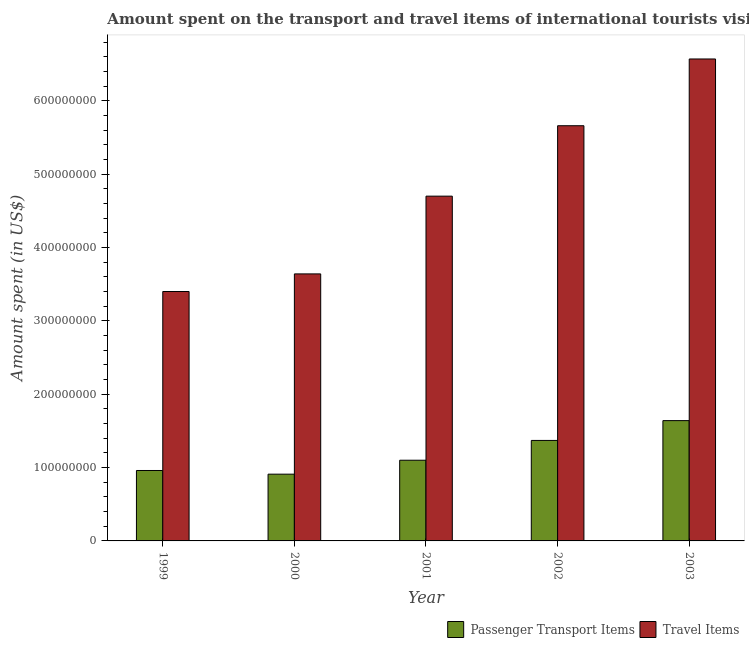How many different coloured bars are there?
Give a very brief answer. 2. What is the label of the 3rd group of bars from the left?
Provide a succinct answer. 2001. In how many cases, is the number of bars for a given year not equal to the number of legend labels?
Offer a terse response. 0. What is the amount spent on passenger transport items in 2001?
Offer a very short reply. 1.10e+08. Across all years, what is the maximum amount spent on passenger transport items?
Your response must be concise. 1.64e+08. Across all years, what is the minimum amount spent on passenger transport items?
Provide a succinct answer. 9.10e+07. In which year was the amount spent on passenger transport items maximum?
Provide a short and direct response. 2003. In which year was the amount spent in travel items minimum?
Offer a very short reply. 1999. What is the total amount spent in travel items in the graph?
Offer a terse response. 2.40e+09. What is the difference between the amount spent on passenger transport items in 2000 and that in 2002?
Offer a very short reply. -4.60e+07. What is the difference between the amount spent in travel items in 1999 and the amount spent on passenger transport items in 2002?
Provide a succinct answer. -2.26e+08. What is the average amount spent on passenger transport items per year?
Offer a very short reply. 1.20e+08. What is the ratio of the amount spent on passenger transport items in 2000 to that in 2003?
Ensure brevity in your answer.  0.55. Is the difference between the amount spent on passenger transport items in 1999 and 2001 greater than the difference between the amount spent in travel items in 1999 and 2001?
Your response must be concise. No. What is the difference between the highest and the second highest amount spent on passenger transport items?
Provide a short and direct response. 2.70e+07. What is the difference between the highest and the lowest amount spent in travel items?
Your response must be concise. 3.17e+08. In how many years, is the amount spent on passenger transport items greater than the average amount spent on passenger transport items taken over all years?
Keep it short and to the point. 2. What does the 2nd bar from the left in 2002 represents?
Keep it short and to the point. Travel Items. What does the 1st bar from the right in 2000 represents?
Offer a terse response. Travel Items. How many bars are there?
Your response must be concise. 10. Are all the bars in the graph horizontal?
Offer a terse response. No. What is the difference between two consecutive major ticks on the Y-axis?
Make the answer very short. 1.00e+08. Are the values on the major ticks of Y-axis written in scientific E-notation?
Offer a very short reply. No. Does the graph contain grids?
Provide a short and direct response. No. Where does the legend appear in the graph?
Offer a very short reply. Bottom right. How many legend labels are there?
Your response must be concise. 2. How are the legend labels stacked?
Your answer should be compact. Horizontal. What is the title of the graph?
Keep it short and to the point. Amount spent on the transport and travel items of international tourists visited in Ukraine. What is the label or title of the X-axis?
Keep it short and to the point. Year. What is the label or title of the Y-axis?
Keep it short and to the point. Amount spent (in US$). What is the Amount spent (in US$) in Passenger Transport Items in 1999?
Your answer should be very brief. 9.60e+07. What is the Amount spent (in US$) in Travel Items in 1999?
Provide a short and direct response. 3.40e+08. What is the Amount spent (in US$) of Passenger Transport Items in 2000?
Provide a succinct answer. 9.10e+07. What is the Amount spent (in US$) in Travel Items in 2000?
Provide a short and direct response. 3.64e+08. What is the Amount spent (in US$) in Passenger Transport Items in 2001?
Provide a short and direct response. 1.10e+08. What is the Amount spent (in US$) in Travel Items in 2001?
Offer a terse response. 4.70e+08. What is the Amount spent (in US$) of Passenger Transport Items in 2002?
Keep it short and to the point. 1.37e+08. What is the Amount spent (in US$) in Travel Items in 2002?
Keep it short and to the point. 5.66e+08. What is the Amount spent (in US$) of Passenger Transport Items in 2003?
Offer a very short reply. 1.64e+08. What is the Amount spent (in US$) in Travel Items in 2003?
Your answer should be very brief. 6.57e+08. Across all years, what is the maximum Amount spent (in US$) of Passenger Transport Items?
Give a very brief answer. 1.64e+08. Across all years, what is the maximum Amount spent (in US$) in Travel Items?
Give a very brief answer. 6.57e+08. Across all years, what is the minimum Amount spent (in US$) of Passenger Transport Items?
Your response must be concise. 9.10e+07. Across all years, what is the minimum Amount spent (in US$) in Travel Items?
Your answer should be very brief. 3.40e+08. What is the total Amount spent (in US$) of Passenger Transport Items in the graph?
Offer a very short reply. 5.98e+08. What is the total Amount spent (in US$) in Travel Items in the graph?
Keep it short and to the point. 2.40e+09. What is the difference between the Amount spent (in US$) of Passenger Transport Items in 1999 and that in 2000?
Provide a short and direct response. 5.00e+06. What is the difference between the Amount spent (in US$) of Travel Items in 1999 and that in 2000?
Your response must be concise. -2.40e+07. What is the difference between the Amount spent (in US$) in Passenger Transport Items in 1999 and that in 2001?
Give a very brief answer. -1.40e+07. What is the difference between the Amount spent (in US$) of Travel Items in 1999 and that in 2001?
Your response must be concise. -1.30e+08. What is the difference between the Amount spent (in US$) of Passenger Transport Items in 1999 and that in 2002?
Keep it short and to the point. -4.10e+07. What is the difference between the Amount spent (in US$) of Travel Items in 1999 and that in 2002?
Give a very brief answer. -2.26e+08. What is the difference between the Amount spent (in US$) of Passenger Transport Items in 1999 and that in 2003?
Ensure brevity in your answer.  -6.80e+07. What is the difference between the Amount spent (in US$) of Travel Items in 1999 and that in 2003?
Give a very brief answer. -3.17e+08. What is the difference between the Amount spent (in US$) in Passenger Transport Items in 2000 and that in 2001?
Make the answer very short. -1.90e+07. What is the difference between the Amount spent (in US$) of Travel Items in 2000 and that in 2001?
Give a very brief answer. -1.06e+08. What is the difference between the Amount spent (in US$) of Passenger Transport Items in 2000 and that in 2002?
Offer a terse response. -4.60e+07. What is the difference between the Amount spent (in US$) of Travel Items in 2000 and that in 2002?
Give a very brief answer. -2.02e+08. What is the difference between the Amount spent (in US$) of Passenger Transport Items in 2000 and that in 2003?
Keep it short and to the point. -7.30e+07. What is the difference between the Amount spent (in US$) in Travel Items in 2000 and that in 2003?
Offer a terse response. -2.93e+08. What is the difference between the Amount spent (in US$) of Passenger Transport Items in 2001 and that in 2002?
Make the answer very short. -2.70e+07. What is the difference between the Amount spent (in US$) of Travel Items in 2001 and that in 2002?
Provide a short and direct response. -9.60e+07. What is the difference between the Amount spent (in US$) of Passenger Transport Items in 2001 and that in 2003?
Make the answer very short. -5.40e+07. What is the difference between the Amount spent (in US$) in Travel Items in 2001 and that in 2003?
Your answer should be compact. -1.87e+08. What is the difference between the Amount spent (in US$) of Passenger Transport Items in 2002 and that in 2003?
Keep it short and to the point. -2.70e+07. What is the difference between the Amount spent (in US$) in Travel Items in 2002 and that in 2003?
Provide a short and direct response. -9.10e+07. What is the difference between the Amount spent (in US$) in Passenger Transport Items in 1999 and the Amount spent (in US$) in Travel Items in 2000?
Your answer should be compact. -2.68e+08. What is the difference between the Amount spent (in US$) of Passenger Transport Items in 1999 and the Amount spent (in US$) of Travel Items in 2001?
Offer a terse response. -3.74e+08. What is the difference between the Amount spent (in US$) in Passenger Transport Items in 1999 and the Amount spent (in US$) in Travel Items in 2002?
Your answer should be compact. -4.70e+08. What is the difference between the Amount spent (in US$) of Passenger Transport Items in 1999 and the Amount spent (in US$) of Travel Items in 2003?
Your answer should be compact. -5.61e+08. What is the difference between the Amount spent (in US$) of Passenger Transport Items in 2000 and the Amount spent (in US$) of Travel Items in 2001?
Provide a short and direct response. -3.79e+08. What is the difference between the Amount spent (in US$) of Passenger Transport Items in 2000 and the Amount spent (in US$) of Travel Items in 2002?
Ensure brevity in your answer.  -4.75e+08. What is the difference between the Amount spent (in US$) in Passenger Transport Items in 2000 and the Amount spent (in US$) in Travel Items in 2003?
Make the answer very short. -5.66e+08. What is the difference between the Amount spent (in US$) in Passenger Transport Items in 2001 and the Amount spent (in US$) in Travel Items in 2002?
Make the answer very short. -4.56e+08. What is the difference between the Amount spent (in US$) in Passenger Transport Items in 2001 and the Amount spent (in US$) in Travel Items in 2003?
Provide a short and direct response. -5.47e+08. What is the difference between the Amount spent (in US$) in Passenger Transport Items in 2002 and the Amount spent (in US$) in Travel Items in 2003?
Offer a terse response. -5.20e+08. What is the average Amount spent (in US$) in Passenger Transport Items per year?
Ensure brevity in your answer.  1.20e+08. What is the average Amount spent (in US$) in Travel Items per year?
Give a very brief answer. 4.79e+08. In the year 1999, what is the difference between the Amount spent (in US$) in Passenger Transport Items and Amount spent (in US$) in Travel Items?
Provide a short and direct response. -2.44e+08. In the year 2000, what is the difference between the Amount spent (in US$) of Passenger Transport Items and Amount spent (in US$) of Travel Items?
Give a very brief answer. -2.73e+08. In the year 2001, what is the difference between the Amount spent (in US$) in Passenger Transport Items and Amount spent (in US$) in Travel Items?
Offer a very short reply. -3.60e+08. In the year 2002, what is the difference between the Amount spent (in US$) of Passenger Transport Items and Amount spent (in US$) of Travel Items?
Offer a terse response. -4.29e+08. In the year 2003, what is the difference between the Amount spent (in US$) in Passenger Transport Items and Amount spent (in US$) in Travel Items?
Your answer should be compact. -4.93e+08. What is the ratio of the Amount spent (in US$) in Passenger Transport Items in 1999 to that in 2000?
Provide a short and direct response. 1.05. What is the ratio of the Amount spent (in US$) in Travel Items in 1999 to that in 2000?
Your response must be concise. 0.93. What is the ratio of the Amount spent (in US$) in Passenger Transport Items in 1999 to that in 2001?
Provide a short and direct response. 0.87. What is the ratio of the Amount spent (in US$) in Travel Items in 1999 to that in 2001?
Your answer should be very brief. 0.72. What is the ratio of the Amount spent (in US$) of Passenger Transport Items in 1999 to that in 2002?
Your response must be concise. 0.7. What is the ratio of the Amount spent (in US$) in Travel Items in 1999 to that in 2002?
Offer a very short reply. 0.6. What is the ratio of the Amount spent (in US$) in Passenger Transport Items in 1999 to that in 2003?
Offer a terse response. 0.59. What is the ratio of the Amount spent (in US$) of Travel Items in 1999 to that in 2003?
Your answer should be compact. 0.52. What is the ratio of the Amount spent (in US$) in Passenger Transport Items in 2000 to that in 2001?
Your answer should be very brief. 0.83. What is the ratio of the Amount spent (in US$) of Travel Items in 2000 to that in 2001?
Your response must be concise. 0.77. What is the ratio of the Amount spent (in US$) of Passenger Transport Items in 2000 to that in 2002?
Your answer should be compact. 0.66. What is the ratio of the Amount spent (in US$) of Travel Items in 2000 to that in 2002?
Offer a very short reply. 0.64. What is the ratio of the Amount spent (in US$) of Passenger Transport Items in 2000 to that in 2003?
Offer a very short reply. 0.55. What is the ratio of the Amount spent (in US$) in Travel Items in 2000 to that in 2003?
Offer a very short reply. 0.55. What is the ratio of the Amount spent (in US$) in Passenger Transport Items in 2001 to that in 2002?
Offer a very short reply. 0.8. What is the ratio of the Amount spent (in US$) of Travel Items in 2001 to that in 2002?
Offer a very short reply. 0.83. What is the ratio of the Amount spent (in US$) of Passenger Transport Items in 2001 to that in 2003?
Provide a short and direct response. 0.67. What is the ratio of the Amount spent (in US$) of Travel Items in 2001 to that in 2003?
Keep it short and to the point. 0.72. What is the ratio of the Amount spent (in US$) in Passenger Transport Items in 2002 to that in 2003?
Ensure brevity in your answer.  0.84. What is the ratio of the Amount spent (in US$) of Travel Items in 2002 to that in 2003?
Keep it short and to the point. 0.86. What is the difference between the highest and the second highest Amount spent (in US$) in Passenger Transport Items?
Offer a very short reply. 2.70e+07. What is the difference between the highest and the second highest Amount spent (in US$) of Travel Items?
Ensure brevity in your answer.  9.10e+07. What is the difference between the highest and the lowest Amount spent (in US$) of Passenger Transport Items?
Your response must be concise. 7.30e+07. What is the difference between the highest and the lowest Amount spent (in US$) in Travel Items?
Your answer should be very brief. 3.17e+08. 